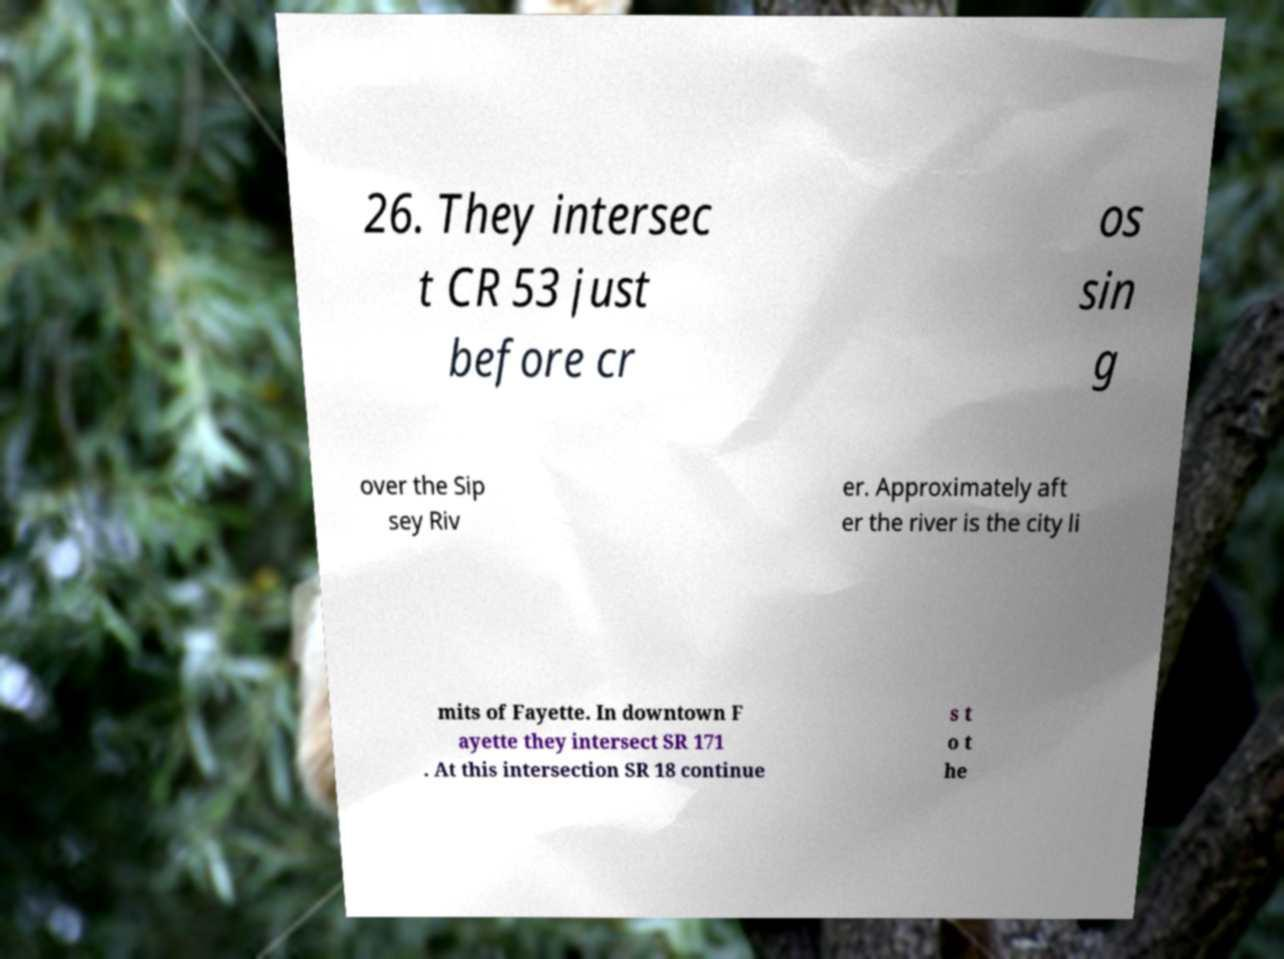There's text embedded in this image that I need extracted. Can you transcribe it verbatim? 26. They intersec t CR 53 just before cr os sin g over the Sip sey Riv er. Approximately aft er the river is the city li mits of Fayette. In downtown F ayette they intersect SR 171 . At this intersection SR 18 continue s t o t he 